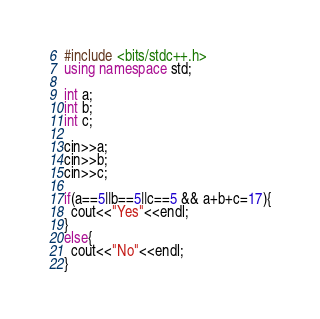<code> <loc_0><loc_0><loc_500><loc_500><_C++_>#include <bits/stdc++.h>
using namespace std;

int a;
int b;
int c;

cin>>a;
cin>>b;
cin>>c;

if(a==5||b==5||c==5 && a+b+c=17){
  cout<<"Yes"<<endl;
}
else{
  cout<<"No"<<endl;
}</code> 